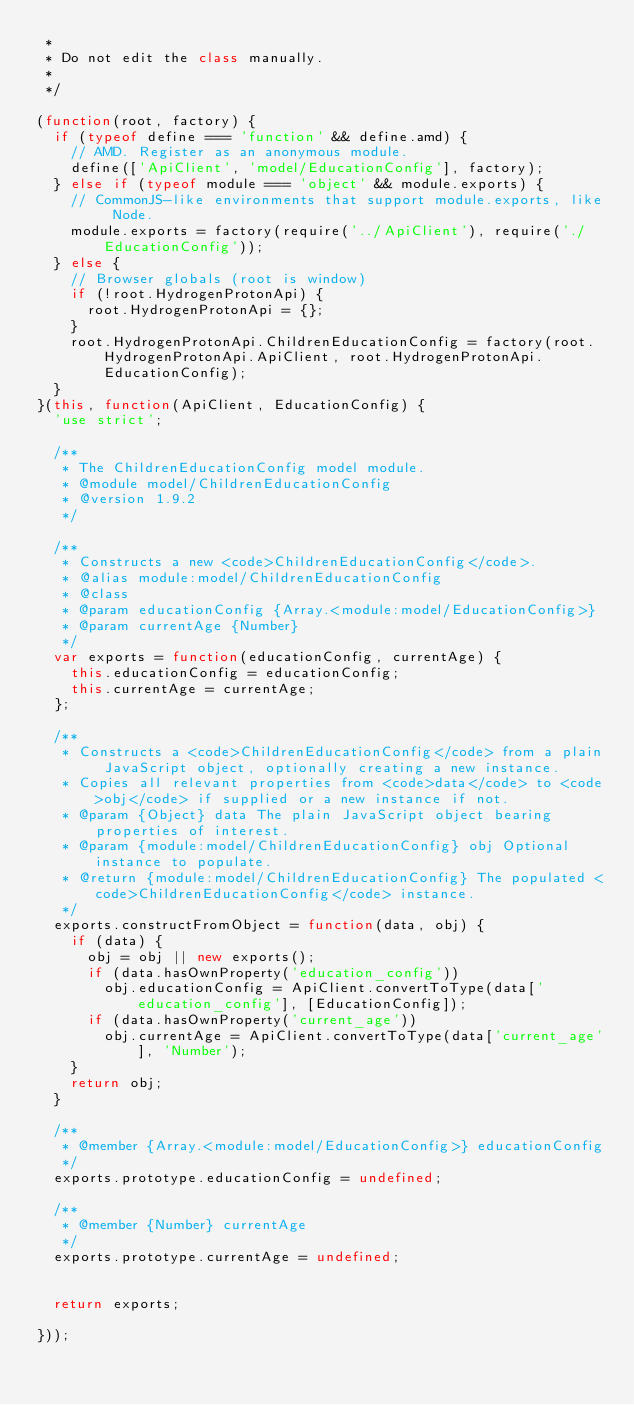<code> <loc_0><loc_0><loc_500><loc_500><_JavaScript_> *
 * Do not edit the class manually.
 *
 */

(function(root, factory) {
  if (typeof define === 'function' && define.amd) {
    // AMD. Register as an anonymous module.
    define(['ApiClient', 'model/EducationConfig'], factory);
  } else if (typeof module === 'object' && module.exports) {
    // CommonJS-like environments that support module.exports, like Node.
    module.exports = factory(require('../ApiClient'), require('./EducationConfig'));
  } else {
    // Browser globals (root is window)
    if (!root.HydrogenProtonApi) {
      root.HydrogenProtonApi = {};
    }
    root.HydrogenProtonApi.ChildrenEducationConfig = factory(root.HydrogenProtonApi.ApiClient, root.HydrogenProtonApi.EducationConfig);
  }
}(this, function(ApiClient, EducationConfig) {
  'use strict';

  /**
   * The ChildrenEducationConfig model module.
   * @module model/ChildrenEducationConfig
   * @version 1.9.2
   */

  /**
   * Constructs a new <code>ChildrenEducationConfig</code>.
   * @alias module:model/ChildrenEducationConfig
   * @class
   * @param educationConfig {Array.<module:model/EducationConfig>} 
   * @param currentAge {Number} 
   */
  var exports = function(educationConfig, currentAge) {
    this.educationConfig = educationConfig;
    this.currentAge = currentAge;
  };

  /**
   * Constructs a <code>ChildrenEducationConfig</code> from a plain JavaScript object, optionally creating a new instance.
   * Copies all relevant properties from <code>data</code> to <code>obj</code> if supplied or a new instance if not.
   * @param {Object} data The plain JavaScript object bearing properties of interest.
   * @param {module:model/ChildrenEducationConfig} obj Optional instance to populate.
   * @return {module:model/ChildrenEducationConfig} The populated <code>ChildrenEducationConfig</code> instance.
   */
  exports.constructFromObject = function(data, obj) {
    if (data) {
      obj = obj || new exports();
      if (data.hasOwnProperty('education_config'))
        obj.educationConfig = ApiClient.convertToType(data['education_config'], [EducationConfig]);
      if (data.hasOwnProperty('current_age'))
        obj.currentAge = ApiClient.convertToType(data['current_age'], 'Number');
    }
    return obj;
  }

  /**
   * @member {Array.<module:model/EducationConfig>} educationConfig
   */
  exports.prototype.educationConfig = undefined;

  /**
   * @member {Number} currentAge
   */
  exports.prototype.currentAge = undefined;


  return exports;

}));
</code> 